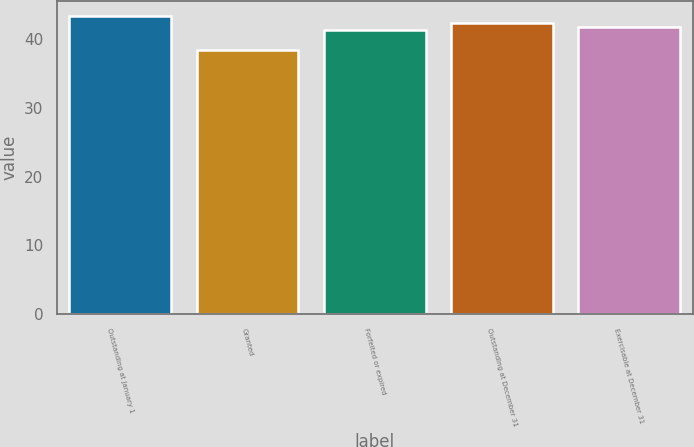Convert chart. <chart><loc_0><loc_0><loc_500><loc_500><bar_chart><fcel>Outstanding at January 1<fcel>Granted<fcel>Forfeited or expired<fcel>Outstanding at December 31<fcel>Exercisable at December 31<nl><fcel>43.43<fcel>38.45<fcel>41.36<fcel>42.36<fcel>41.86<nl></chart> 